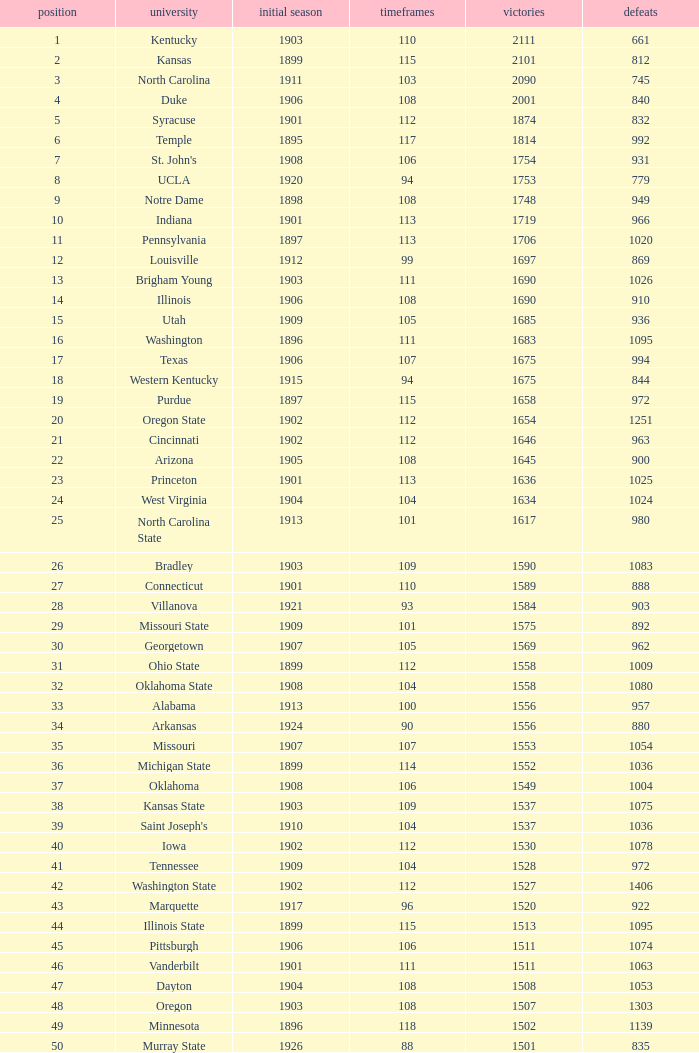What is the total of First Season games with 1537 Wins and a Season greater than 109? None. 